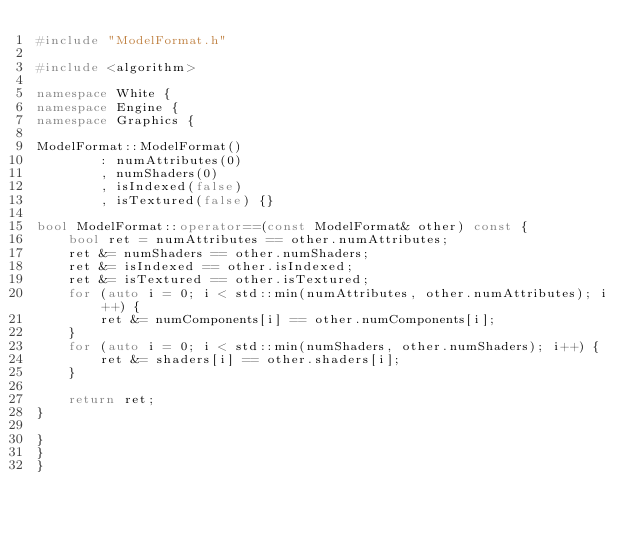<code> <loc_0><loc_0><loc_500><loc_500><_C++_>#include "ModelFormat.h"

#include <algorithm>

namespace White {
namespace Engine {
namespace Graphics {

ModelFormat::ModelFormat() 
        : numAttributes(0)
        , numShaders(0)
        , isIndexed(false)
        , isTextured(false) {}

bool ModelFormat::operator==(const ModelFormat& other) const {
    bool ret = numAttributes == other.numAttributes;
    ret &= numShaders == other.numShaders;
    ret &= isIndexed == other.isIndexed;
    ret &= isTextured == other.isTextured;
    for (auto i = 0; i < std::min(numAttributes, other.numAttributes); i++) {
        ret &= numComponents[i] == other.numComponents[i];
    }
    for (auto i = 0; i < std::min(numShaders, other.numShaders); i++) {
        ret &= shaders[i] == other.shaders[i];
    }

    return ret;
}

}
}
}
</code> 